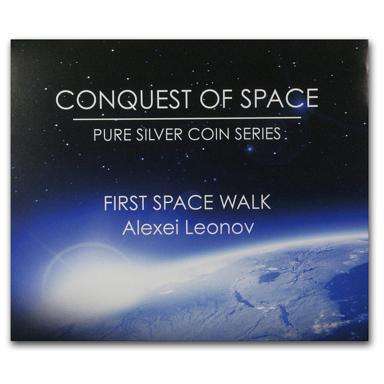What details can you share about the 'Conquest of Space' coin series? The 'Conquest of Space' is a commemorative coin series crafted from pure silver, celebrating monumental events in the odyssey of space exploration. Each coin in the series typically features an iconic moment or milestone from our celestial endeavors, depicted with intricate engravings or images, and is often sought after by collectors and space enthusiasts alike. They serve not only as legal tender but also as artistic tributes to human achievements in space. 